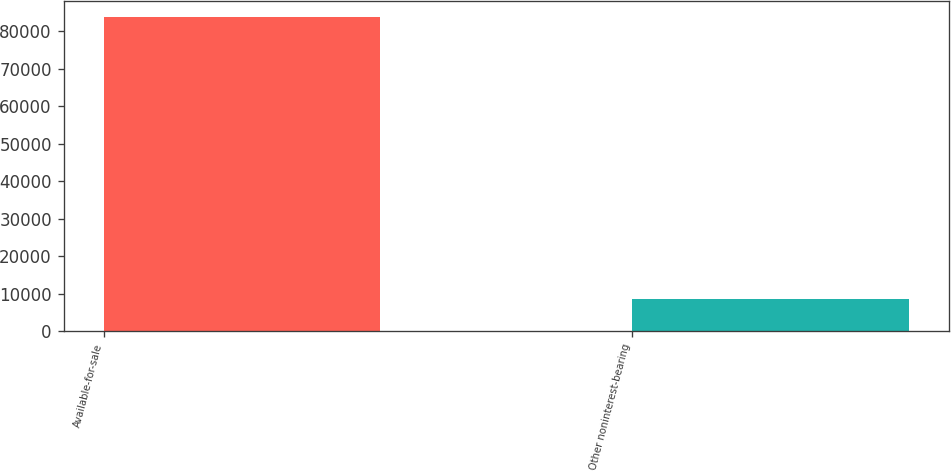Convert chart. <chart><loc_0><loc_0><loc_500><loc_500><bar_chart><fcel>Available-for-sale<fcel>Other noninterest-bearing<nl><fcel>83815<fcel>8544<nl></chart> 